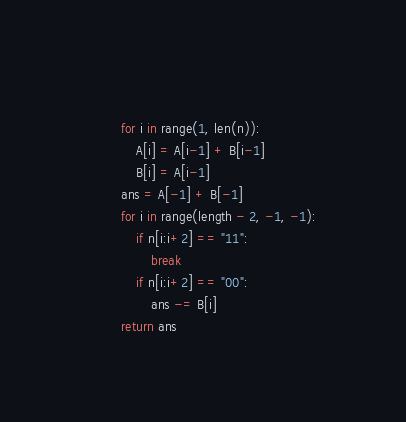<code> <loc_0><loc_0><loc_500><loc_500><_Python_>    
        for i in range(1, len(n)):
            A[i] = A[i-1] + B[i-1]
            B[i] = A[i-1]
        ans = A[-1] + B[-1]
        for i in range(length - 2, -1, -1):
            if n[i:i+2] == "11":
                break
            if n[i:i+2] == "00":
                ans -= B[i]
        return ans</code> 